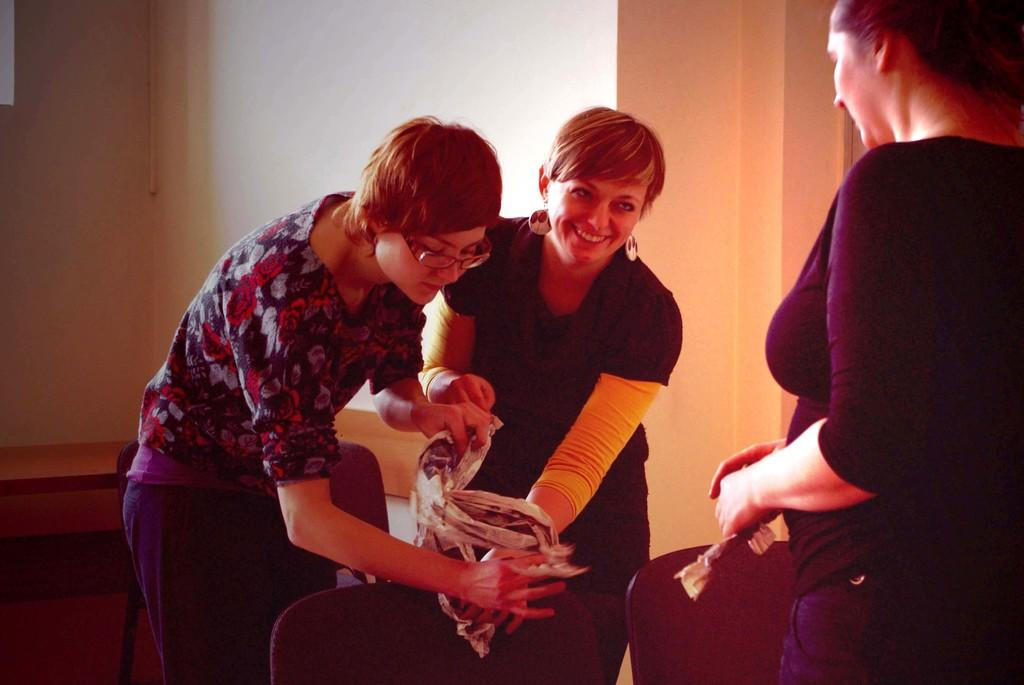How many persons are visible in the image? There are persons in the image, but the exact number cannot be determined from the provided facts. What are the persons sitting on in the image? There are chairs in the image, which the persons might be sitting on. What other objects can be seen in the image besides the chairs? There are other objects in the image, but their specific nature cannot be determined from the provided facts. What is visible in the background of the image? There is a wall and other objects in the background of the image. What type of popcorn is being served in the image? There is no popcorn present in the image. What is the computer system used by the persons in the image? There is no mention of a computer system or any electronic devices in the image. 